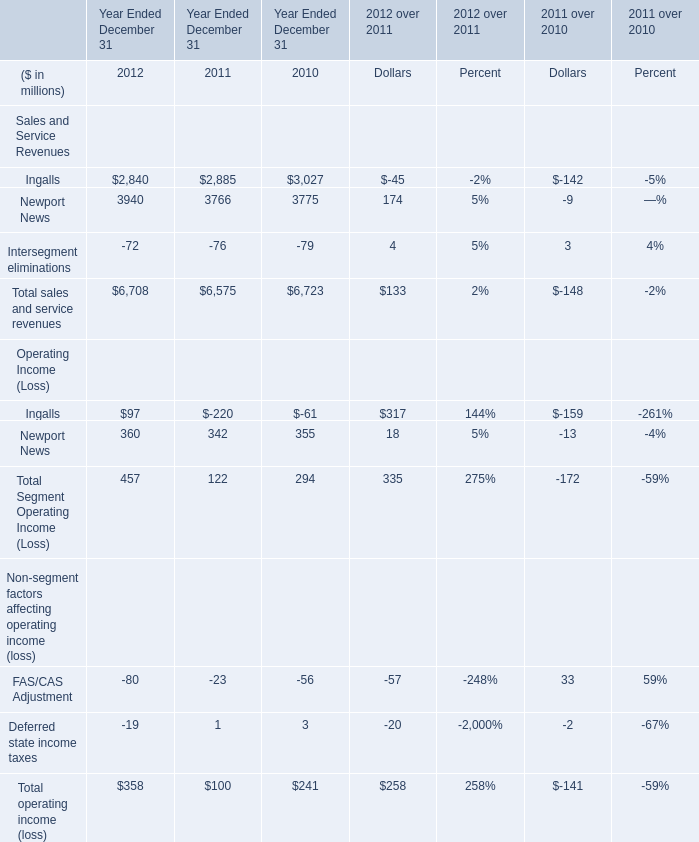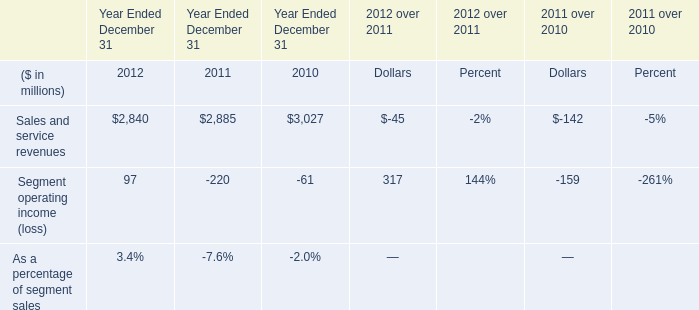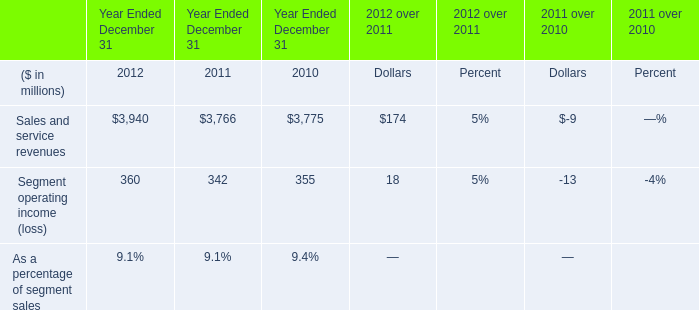What is the difference between 2011 and 2012 's highest sales and service revenues? (in million) 
Computations: (3940 - 3766)
Answer: 174.0. 